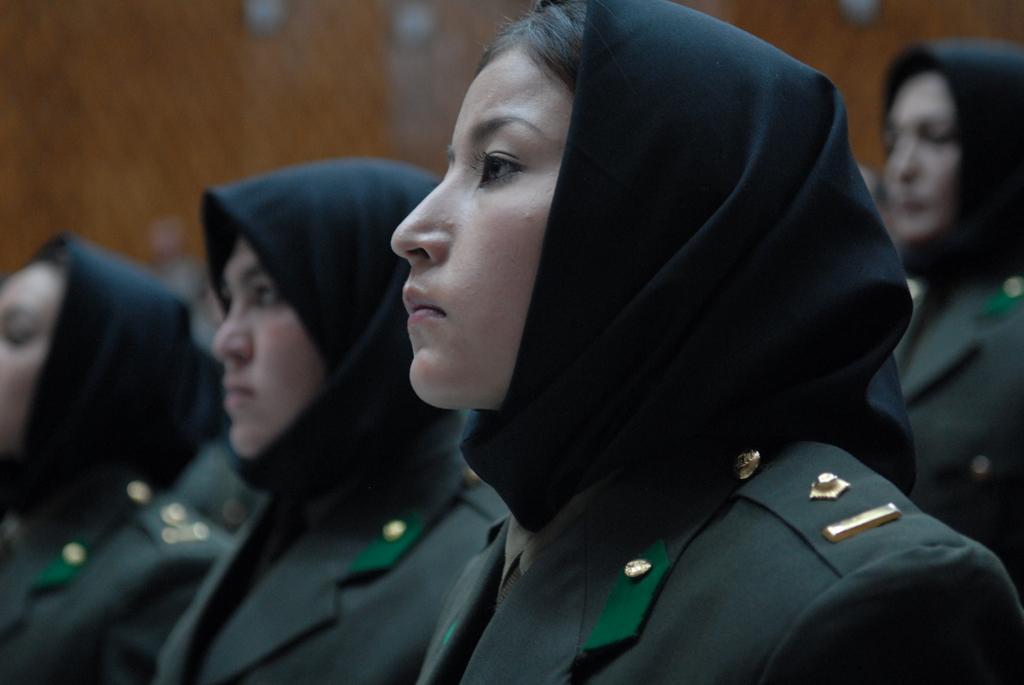Can you describe this image briefly? In this image we can see a few people and in the background, we can see the wall. 